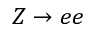Convert formula to latex. <formula><loc_0><loc_0><loc_500><loc_500>Z \to e e</formula> 